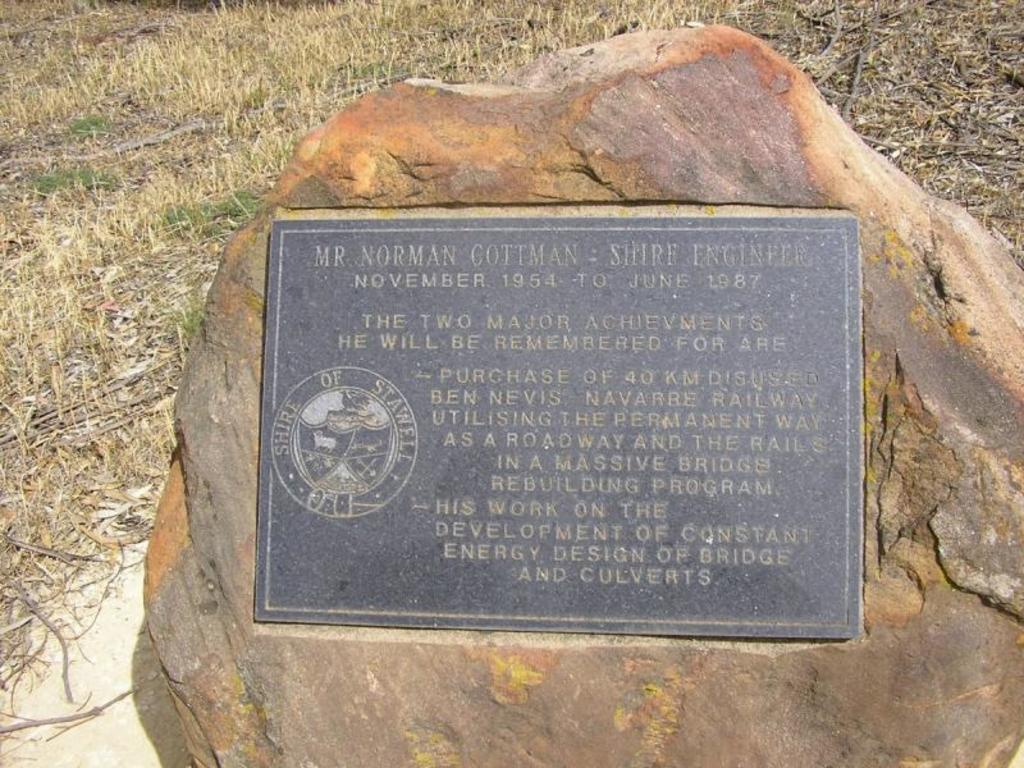What is the main object in the image? There is a marble board in the image. What is the surface of the marble board placed on? The marble board is on a stone surface. What type of ground is visible in the image? There is grass ground visible in the image. Where is the amusement park located in the image? There is no amusement park present in the image. Can you tell me how many pots are on the grass ground in the image? There is no pot present in the image; only a marble board and a stone surface are visible. 